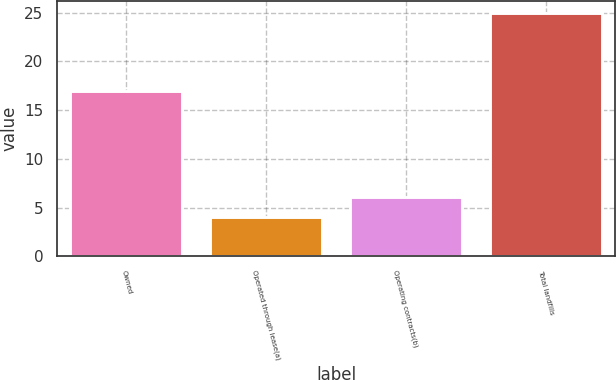<chart> <loc_0><loc_0><loc_500><loc_500><bar_chart><fcel>Owned<fcel>Operated through lease(a)<fcel>Operating contracts(b)<fcel>Total landfills<nl><fcel>17<fcel>4<fcel>6.1<fcel>25<nl></chart> 